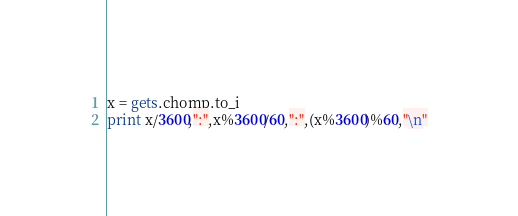Convert code to text. <code><loc_0><loc_0><loc_500><loc_500><_Ruby_>x = gets.chomp.to_i
print x/3600,":",x%3600/60,":",(x%3600)%60,"\n"</code> 